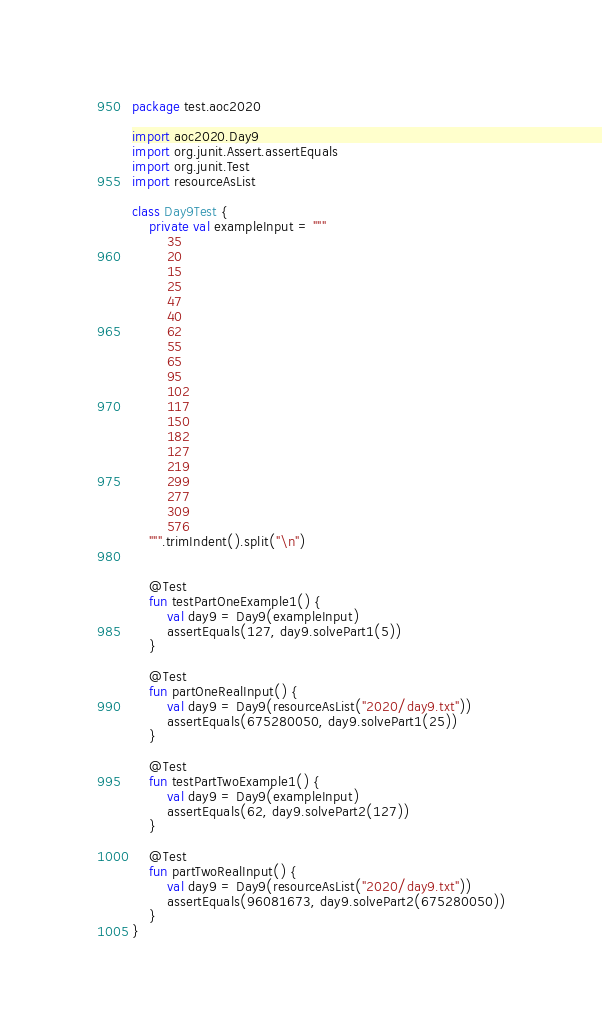Convert code to text. <code><loc_0><loc_0><loc_500><loc_500><_Kotlin_>package test.aoc2020

import aoc2020.Day9
import org.junit.Assert.assertEquals
import org.junit.Test
import resourceAsList

class Day9Test {
    private val exampleInput = """
        35
        20
        15
        25
        47
        40
        62
        55
        65
        95
        102
        117
        150
        182
        127
        219
        299
        277
        309
        576
    """.trimIndent().split("\n")


    @Test
    fun testPartOneExample1() {
        val day9 = Day9(exampleInput)
        assertEquals(127, day9.solvePart1(5))
    }

    @Test
    fun partOneRealInput() {
        val day9 = Day9(resourceAsList("2020/day9.txt"))
        assertEquals(675280050, day9.solvePart1(25))
    }

    @Test
    fun testPartTwoExample1() {
        val day9 = Day9(exampleInput)
        assertEquals(62, day9.solvePart2(127))
    }

    @Test
    fun partTwoRealInput() {
        val day9 = Day9(resourceAsList("2020/day9.txt"))
        assertEquals(96081673, day9.solvePart2(675280050))
    }
}</code> 